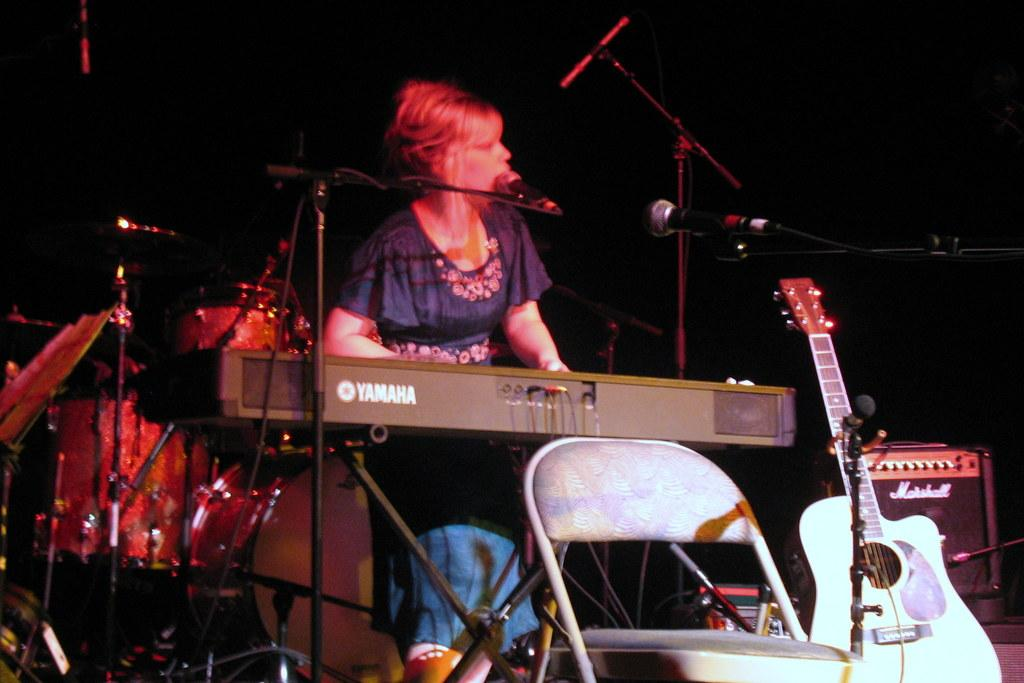What is the woman in the image doing? The woman is playing a piano and singing a song. How is she amplifying her voice? She is using a microphone. What other musical instrument is present in the image? There is a guitar in the image. Where is the guitar placed in relation to the piano? The guitar is placed opposite to the piano. What type of chair is in the image? The chair is placed open. Can you see any friends joining the woman in the image? There is no mention of friends joining the woman in the image. Is there a harbor visible in the image? There is no harbor present in the image. 